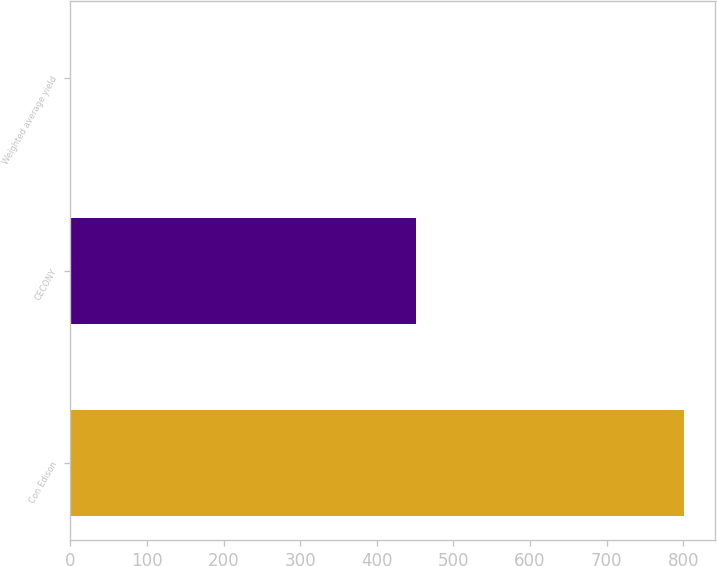Convert chart. <chart><loc_0><loc_0><loc_500><loc_500><bar_chart><fcel>Con Edison<fcel>CECONY<fcel>Weighted average yield<nl><fcel>801<fcel>451<fcel>0.4<nl></chart> 